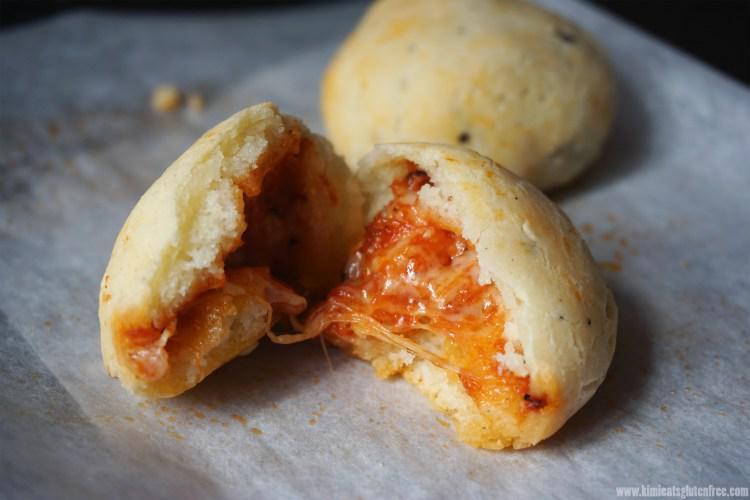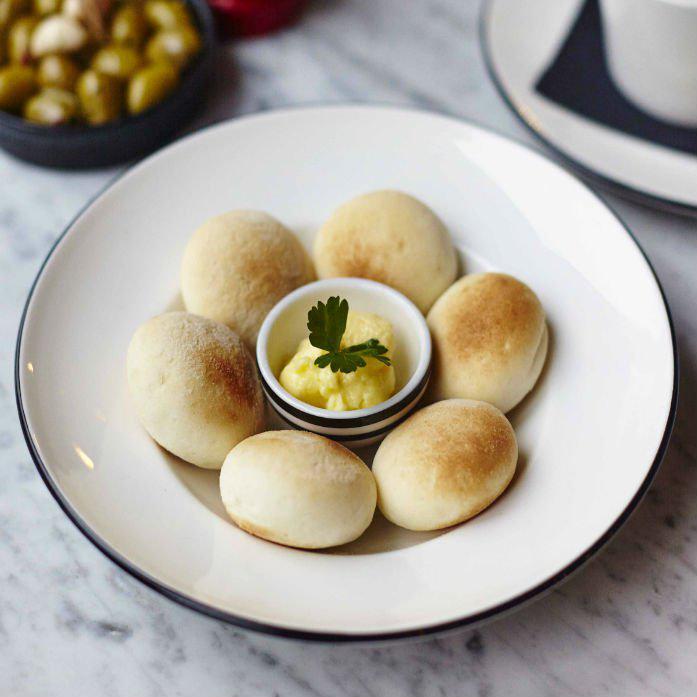The first image is the image on the left, the second image is the image on the right. Evaluate the accuracy of this statement regarding the images: "Dough is resting on a wooden surface in both pictures.". Is it true? Answer yes or no. No. 